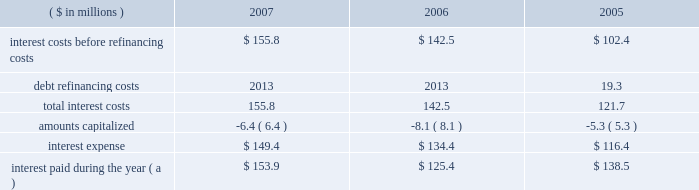Page 59 of 94 notes to consolidated financial statements ball corporation and subsidiaries 13 .
Debt and interest costs ( continued ) long-term debt obligations outstanding at december 31 , 2007 , have maturities of $ 127.1 million , $ 160 million , $ 388.4 million , $ 625.1 million and $ 550.3 million for the years ending december 31 , 2008 through 2012 , respectively , and $ 456.1 million thereafter .
Ball provides letters of credit in the ordinary course of business to secure liabilities recorded in connection with industrial development revenue bonds and certain self-insurance arrangements .
Letters of credit outstanding at december 31 , 2007 and 2006 , were $ 41 million and $ 52.4 million , respectively .
The notes payable and senior credit facilities are guaranteed on a full , unconditional and joint and several basis by certain of the company 2019s domestic wholly owned subsidiaries .
Certain foreign denominated tranches of the senior credit facilities are similarly guaranteed by certain of the company 2019s wholly owned foreign subsidiaries .
Note 22 contains further details as well as condensed , consolidating financial information for the company , segregating the guarantor subsidiaries and non-guarantor subsidiaries .
The company was not in default of any loan agreement at december 31 , 2007 , and has met all debt payment obligations .
The u.s .
Note agreements , bank credit agreement and industrial development revenue bond agreements contain certain restrictions relating to dividend payments , share repurchases , investments , financial ratios , guarantees and the incurrence of additional indebtedness .
On march 27 , 2006 , ball expanded its senior secured credit facilities with the addition of a $ 500 million term d loan facility due in installments through october 2011 .
Also on march 27 , 2006 , ball issued at a price of 99.799 percent $ 450 million of 6.625% ( 6.625 % ) senior notes ( effective yield to maturity of 6.65 percent ) due in march 2018 .
The proceeds from these financings were used to refinance existing u.s .
Can debt with ball corporation debt at lower interest rates , acquire certain north american plastic container net assets from alcan and reduce seasonal working capital debt .
( see note 3 for further details of the acquisitions. ) on october 13 , 2005 , ball refinanced its senior secured credit facilities to extend debt maturities at lower interest rate spreads and provide the company with additional borrowing capacity for future growth .
During the third and fourth quarters of 2005 , ball redeemed its 7.75% ( 7.75 % ) senior notes due in august 2006 .
The refinancing and senior note redemptions resulted in a debt refinancing charge of $ 19.3 million ( $ 12.3 million after tax ) for the related call premium and unamortized debt issuance costs .
A summary of total interest cost paid and accrued follows: .
( a ) includes $ 6.6 million paid in 2005 in connection with the redemption of the company 2019s senior and senior subordinated notes. .
What is the percentage change in interest expense from 2006 to 2007? 
Computations: ((149.4 - 134.4) / 134.4)
Answer: 0.11161. Page 59 of 94 notes to consolidated financial statements ball corporation and subsidiaries 13 .
Debt and interest costs ( continued ) long-term debt obligations outstanding at december 31 , 2007 , have maturities of $ 127.1 million , $ 160 million , $ 388.4 million , $ 625.1 million and $ 550.3 million for the years ending december 31 , 2008 through 2012 , respectively , and $ 456.1 million thereafter .
Ball provides letters of credit in the ordinary course of business to secure liabilities recorded in connection with industrial development revenue bonds and certain self-insurance arrangements .
Letters of credit outstanding at december 31 , 2007 and 2006 , were $ 41 million and $ 52.4 million , respectively .
The notes payable and senior credit facilities are guaranteed on a full , unconditional and joint and several basis by certain of the company 2019s domestic wholly owned subsidiaries .
Certain foreign denominated tranches of the senior credit facilities are similarly guaranteed by certain of the company 2019s wholly owned foreign subsidiaries .
Note 22 contains further details as well as condensed , consolidating financial information for the company , segregating the guarantor subsidiaries and non-guarantor subsidiaries .
The company was not in default of any loan agreement at december 31 , 2007 , and has met all debt payment obligations .
The u.s .
Note agreements , bank credit agreement and industrial development revenue bond agreements contain certain restrictions relating to dividend payments , share repurchases , investments , financial ratios , guarantees and the incurrence of additional indebtedness .
On march 27 , 2006 , ball expanded its senior secured credit facilities with the addition of a $ 500 million term d loan facility due in installments through october 2011 .
Also on march 27 , 2006 , ball issued at a price of 99.799 percent $ 450 million of 6.625% ( 6.625 % ) senior notes ( effective yield to maturity of 6.65 percent ) due in march 2018 .
The proceeds from these financings were used to refinance existing u.s .
Can debt with ball corporation debt at lower interest rates , acquire certain north american plastic container net assets from alcan and reduce seasonal working capital debt .
( see note 3 for further details of the acquisitions. ) on october 13 , 2005 , ball refinanced its senior secured credit facilities to extend debt maturities at lower interest rate spreads and provide the company with additional borrowing capacity for future growth .
During the third and fourth quarters of 2005 , ball redeemed its 7.75% ( 7.75 % ) senior notes due in august 2006 .
The refinancing and senior note redemptions resulted in a debt refinancing charge of $ 19.3 million ( $ 12.3 million after tax ) for the related call premium and unamortized debt issuance costs .
A summary of total interest cost paid and accrued follows: .
( a ) includes $ 6.6 million paid in 2005 in connection with the redemption of the company 2019s senior and senior subordinated notes. .
What are the expected annual cash interest costs for the 6.625% ( 6.625 % ) senior notes? 
Computations: ((450 * 1000000) * 6.625%)
Answer: 29812500.0. 